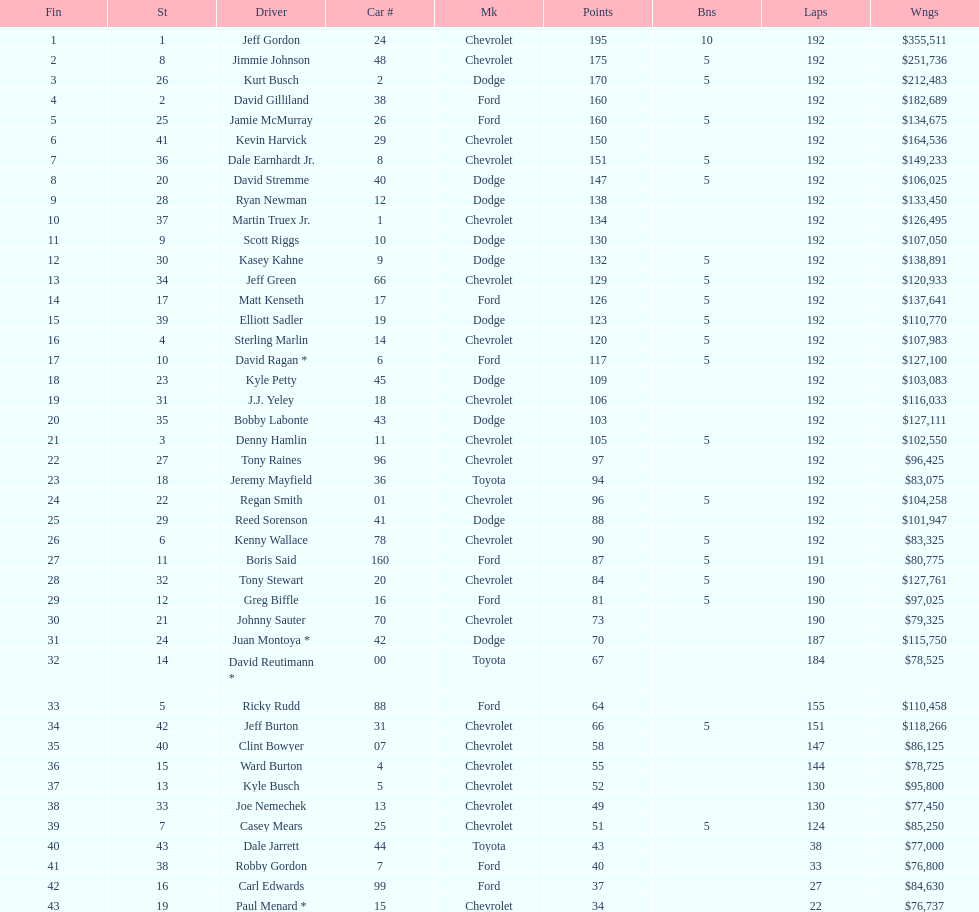Who is first in number of winnings on this list? Jeff Gordon. 